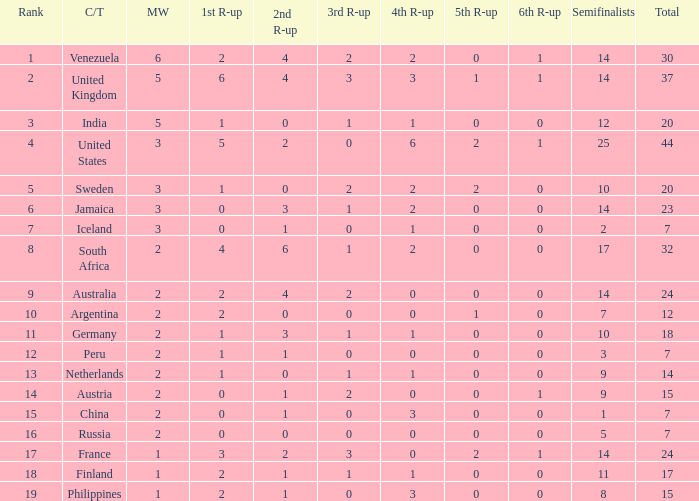What is Iceland's total? 1.0. 